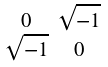Convert formula to latex. <formula><loc_0><loc_0><loc_500><loc_500>\begin{smallmatrix} 0 & \sqrt { - 1 } \\ \sqrt { - 1 } & 0 \end{smallmatrix}</formula> 